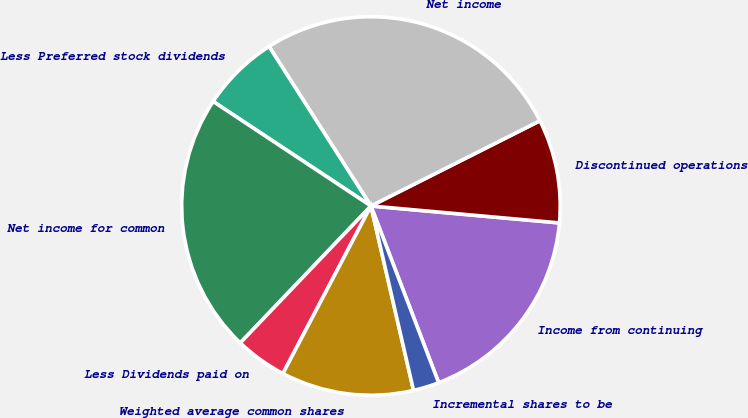<chart> <loc_0><loc_0><loc_500><loc_500><pie_chart><fcel>Income from continuing<fcel>Discontinued operations<fcel>Net income<fcel>Less Preferred stock dividends<fcel>Net income for common<fcel>Less Dividends paid on<fcel>Weighted average common shares<fcel>Incremental shares to be<nl><fcel>17.75%<fcel>8.86%<fcel>26.61%<fcel>6.64%<fcel>22.18%<fcel>4.43%<fcel>11.31%<fcel>2.21%<nl></chart> 